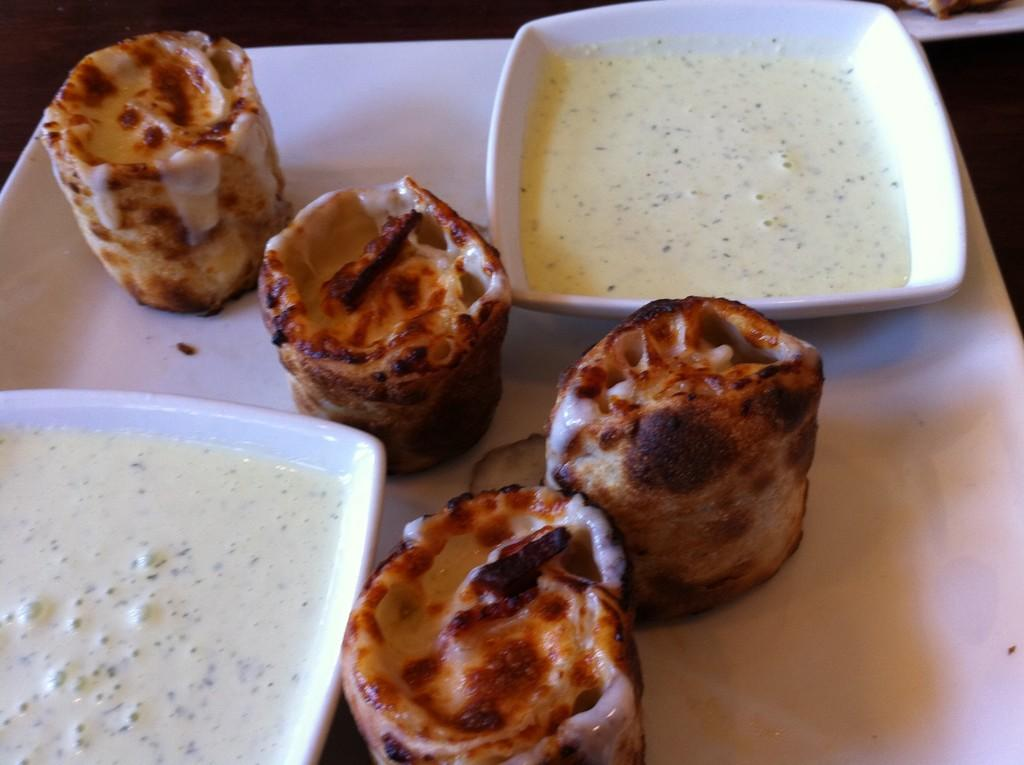What is present on the plate in the image? There are two cups of sauce on the plate. What else can be seen on the plate besides the cups of sauce? There is food in the image. What type of key is used to unlock the food in the image? There is no key present in the image, and the food does not require unlocking. How many pears are visible in the image? There are no pears present in the image. 